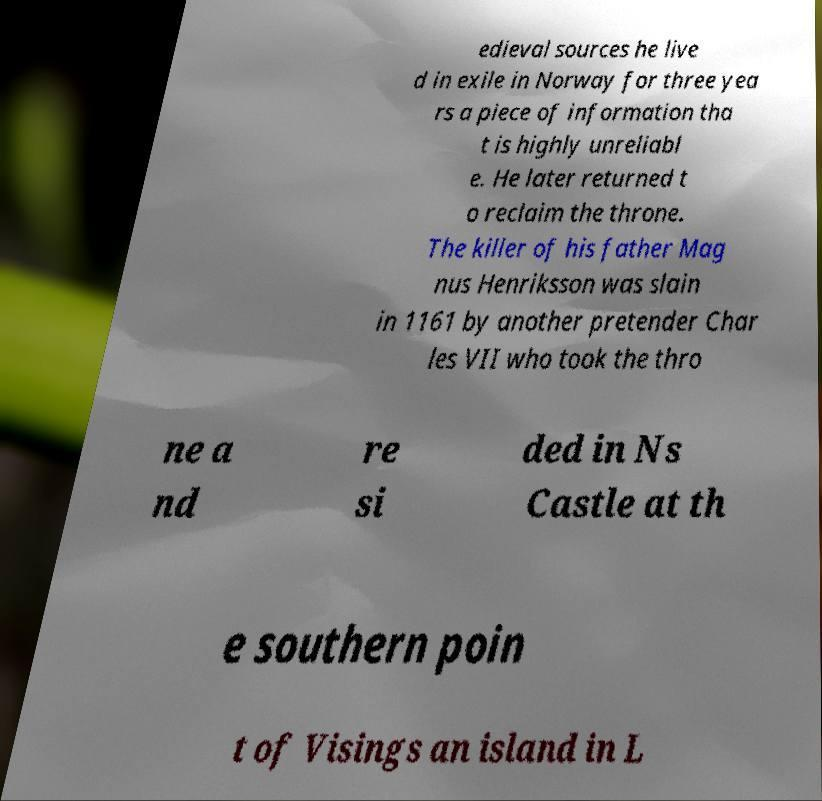I need the written content from this picture converted into text. Can you do that? edieval sources he live d in exile in Norway for three yea rs a piece of information tha t is highly unreliabl e. He later returned t o reclaim the throne. The killer of his father Mag nus Henriksson was slain in 1161 by another pretender Char les VII who took the thro ne a nd re si ded in Ns Castle at th e southern poin t of Visings an island in L 